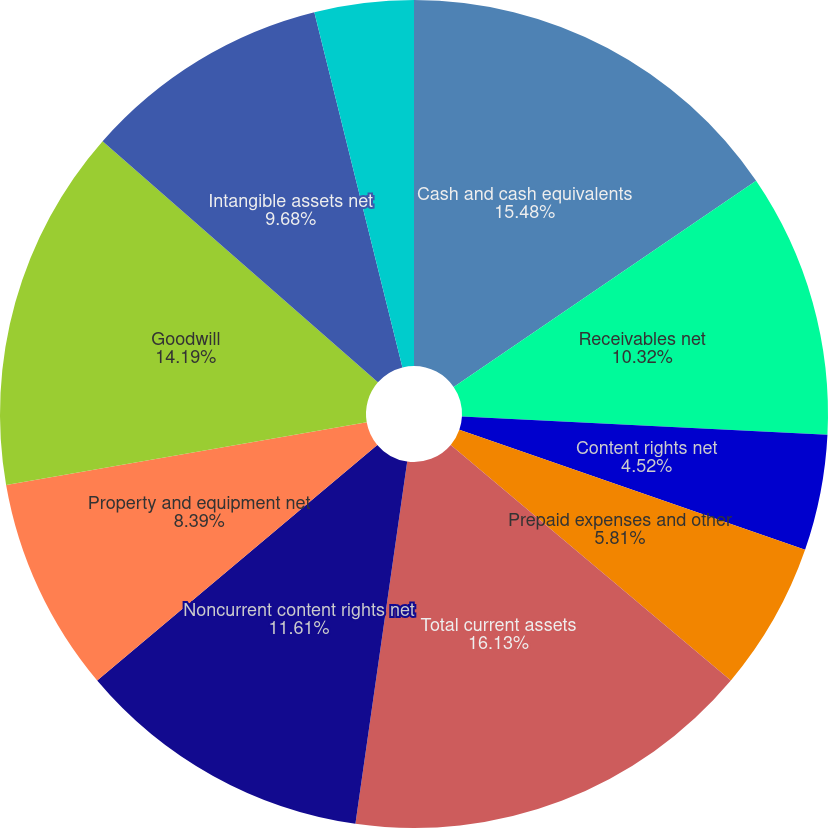Convert chart. <chart><loc_0><loc_0><loc_500><loc_500><pie_chart><fcel>Cash and cash equivalents<fcel>Receivables net<fcel>Content rights net<fcel>Prepaid expenses and other<fcel>Total current assets<fcel>Noncurrent content rights net<fcel>Property and equipment net<fcel>Goodwill<fcel>Intangible assets net<fcel>Equity method investments<nl><fcel>15.48%<fcel>10.32%<fcel>4.52%<fcel>5.81%<fcel>16.13%<fcel>11.61%<fcel>8.39%<fcel>14.19%<fcel>9.68%<fcel>3.87%<nl></chart> 